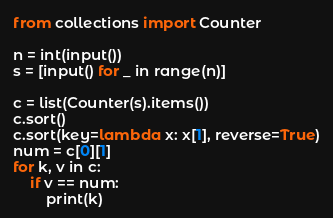Convert code to text. <code><loc_0><loc_0><loc_500><loc_500><_Python_>from collections import Counter

n = int(input())
s = [input() for _ in range(n)]

c = list(Counter(s).items())
c.sort()
c.sort(key=lambda x: x[1], reverse=True)
num = c[0][1]
for k, v in c:
    if v == num:
        print(k)
</code> 